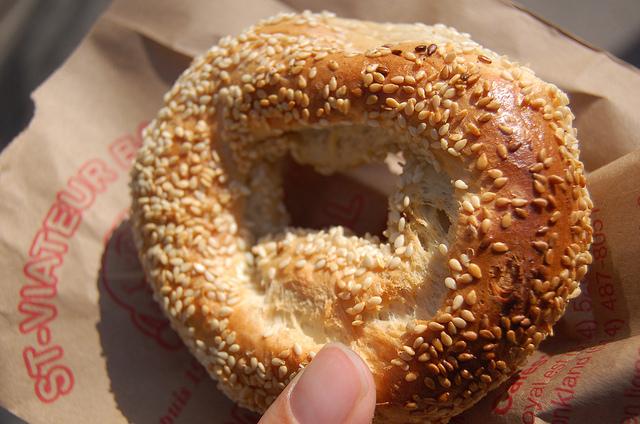What kind of seeds are those?
Quick response, please. Sesame. Is this edible?
Quick response, please. Yes. What race is the person holding the food?
Keep it brief. White. 